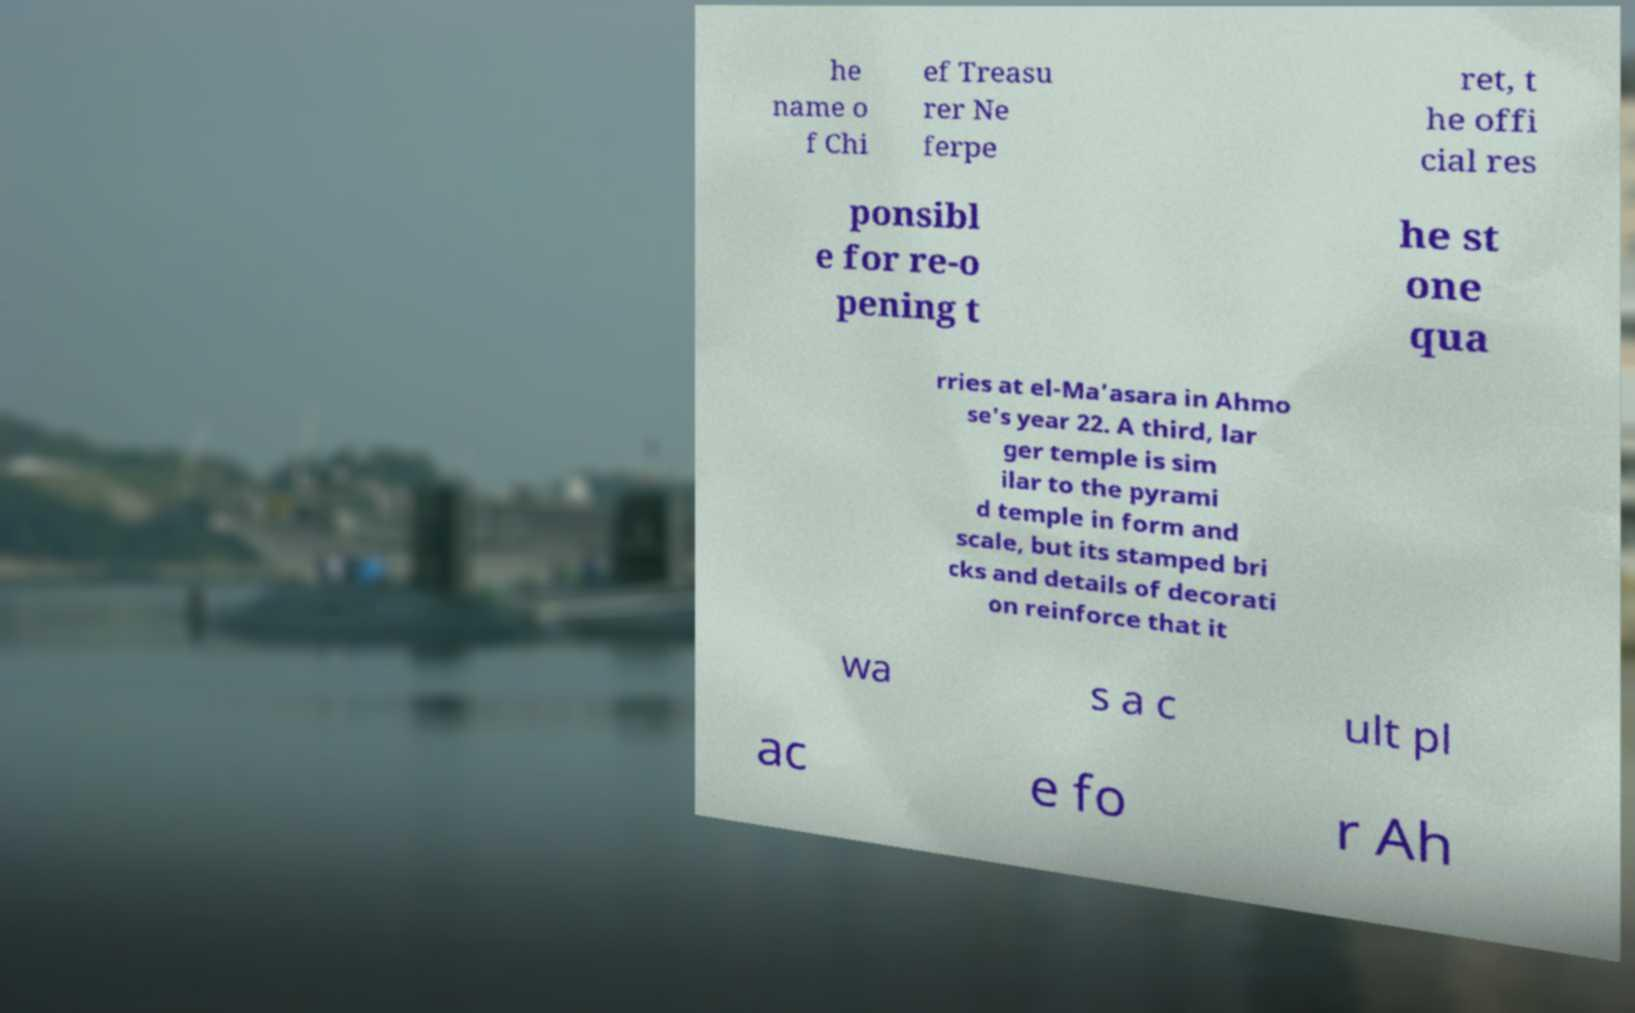Could you assist in decoding the text presented in this image and type it out clearly? he name o f Chi ef Treasu rer Ne ferpe ret, t he offi cial res ponsibl e for re-o pening t he st one qua rries at el-Ma'asara in Ahmo se's year 22. A third, lar ger temple is sim ilar to the pyrami d temple in form and scale, but its stamped bri cks and details of decorati on reinforce that it wa s a c ult pl ac e fo r Ah 